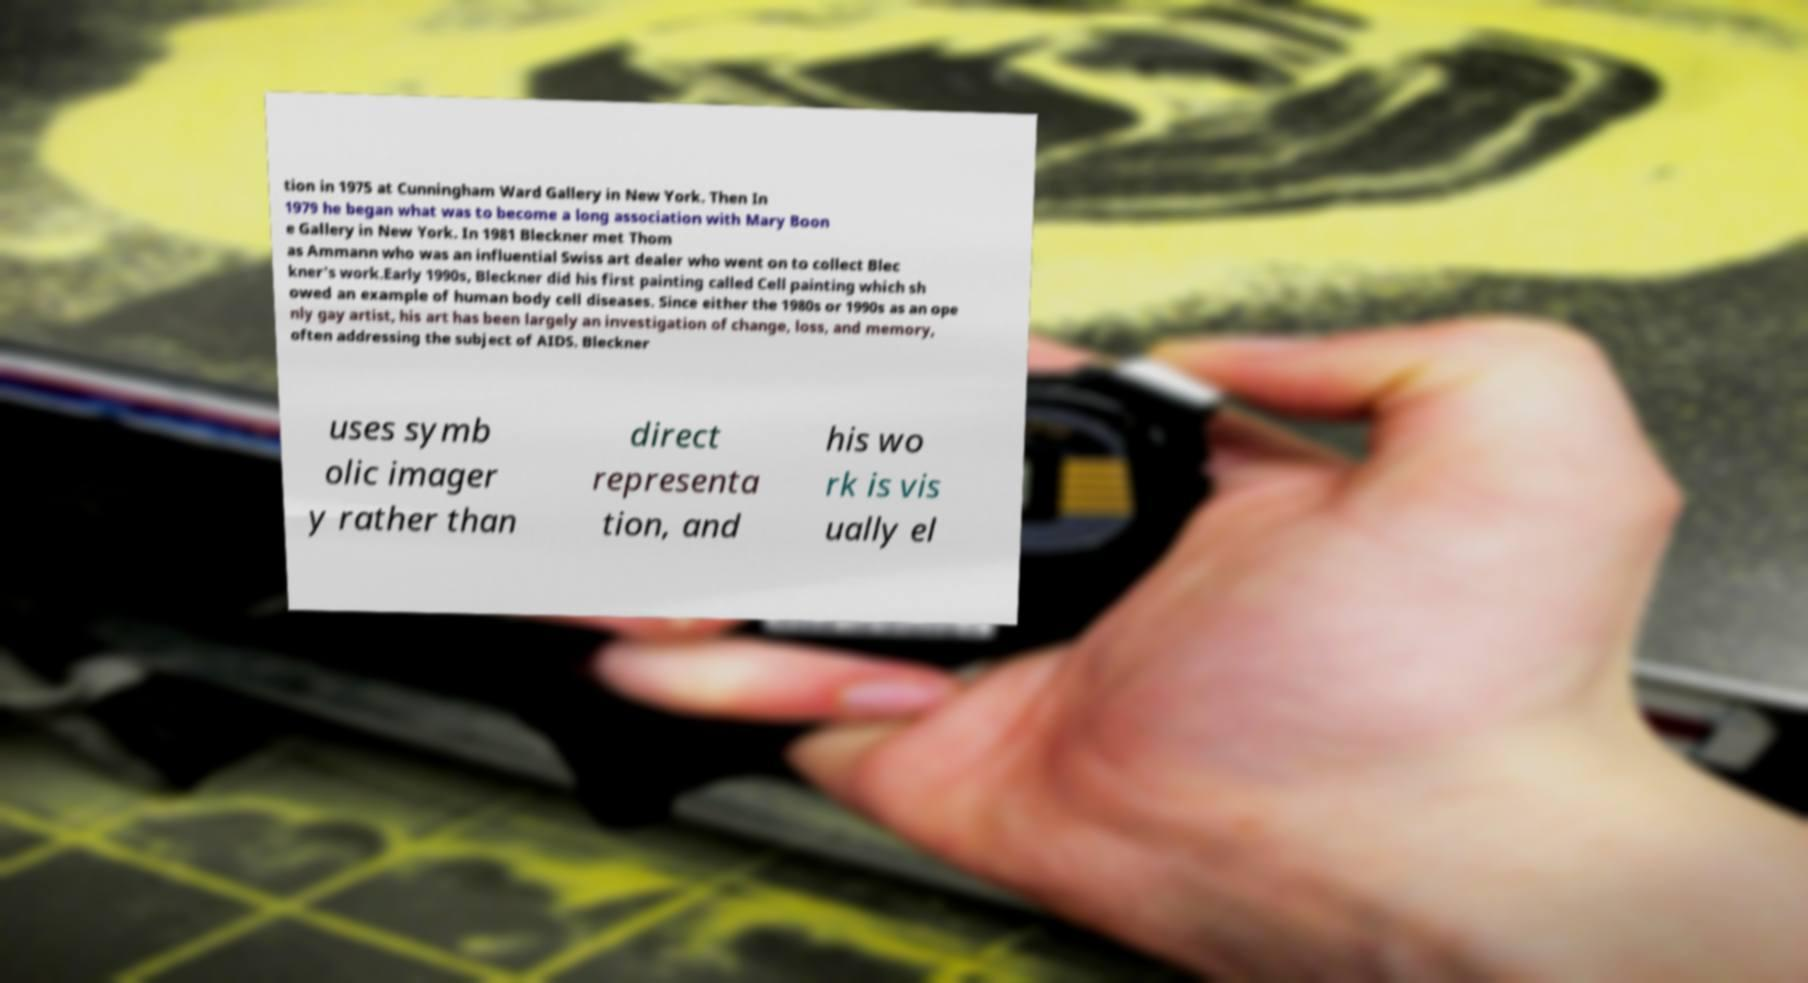I need the written content from this picture converted into text. Can you do that? tion in 1975 at Cunningham Ward Gallery in New York. Then In 1979 he began what was to become a long association with Mary Boon e Gallery in New York. In 1981 Bleckner met Thom as Ammann who was an influential Swiss art dealer who went on to collect Blec kner's work.Early 1990s, Bleckner did his first painting called Cell painting which sh owed an example of human body cell diseases. Since either the 1980s or 1990s as an ope nly gay artist, his art has been largely an investigation of change, loss, and memory, often addressing the subject of AIDS. Bleckner uses symb olic imager y rather than direct representa tion, and his wo rk is vis ually el 